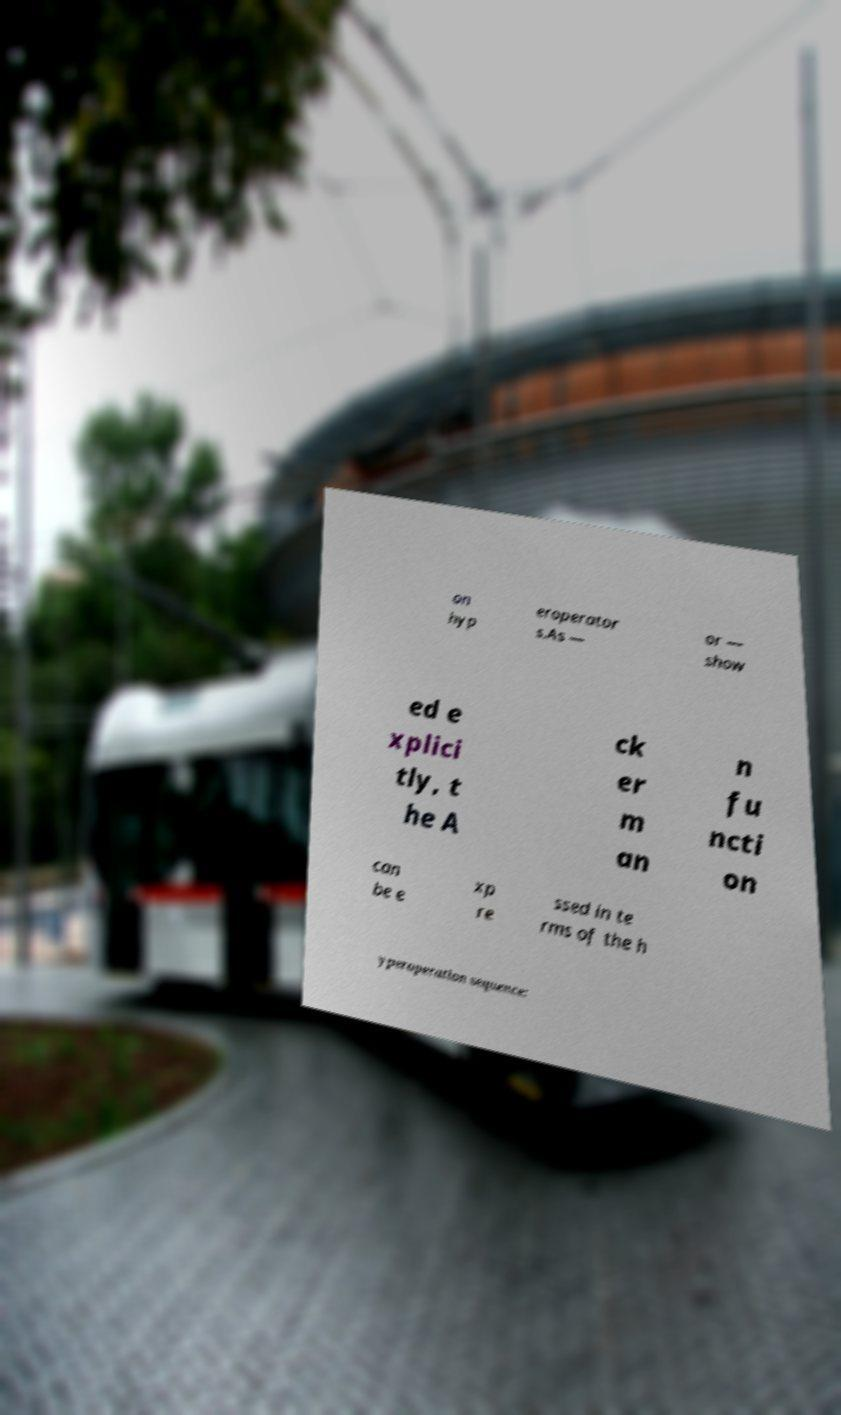Please read and relay the text visible in this image. What does it say? on hyp eroperator s.As — or — show ed e xplici tly, t he A ck er m an n fu ncti on can be e xp re ssed in te rms of the h yperoperation sequence: 